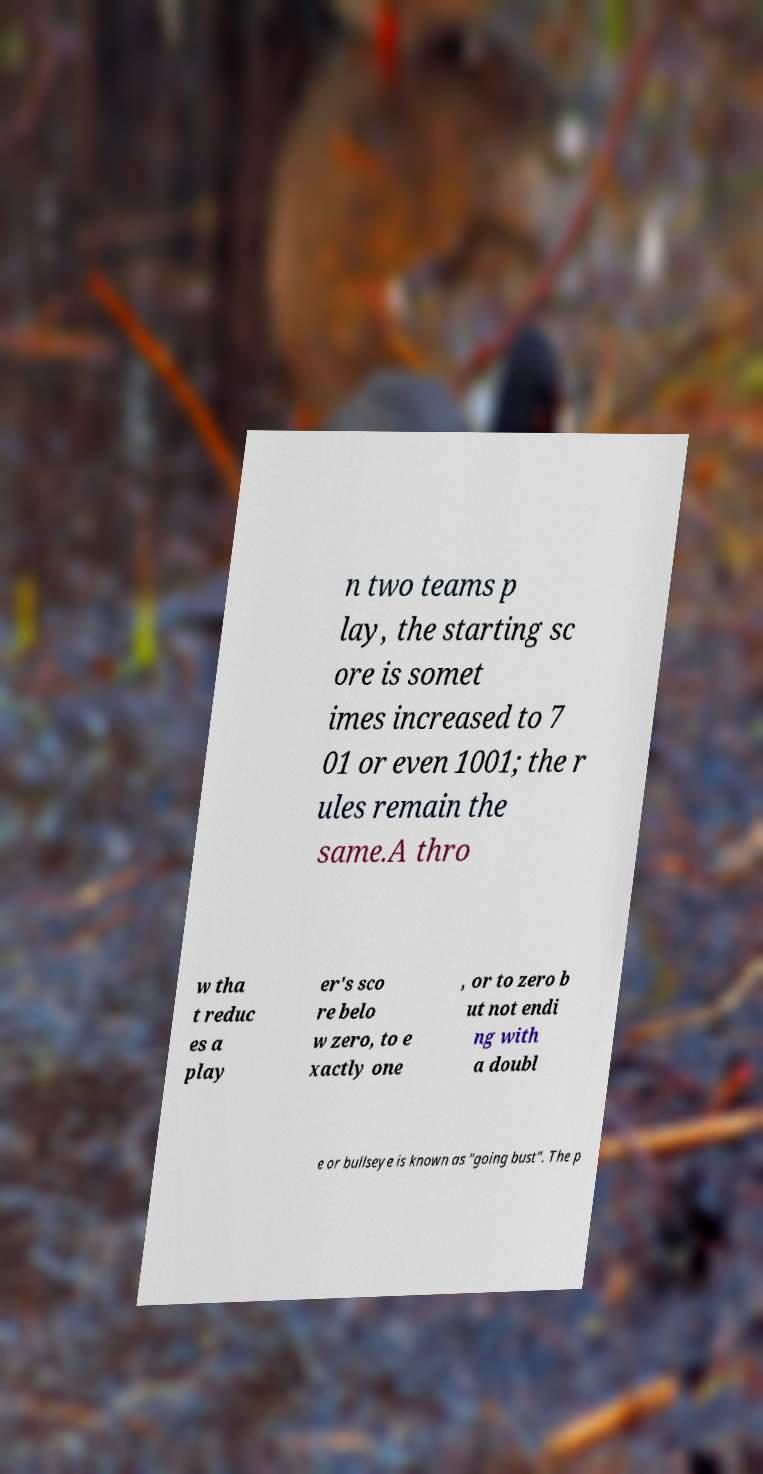Could you assist in decoding the text presented in this image and type it out clearly? n two teams p lay, the starting sc ore is somet imes increased to 7 01 or even 1001; the r ules remain the same.A thro w tha t reduc es a play er's sco re belo w zero, to e xactly one , or to zero b ut not endi ng with a doubl e or bullseye is known as "going bust". The p 